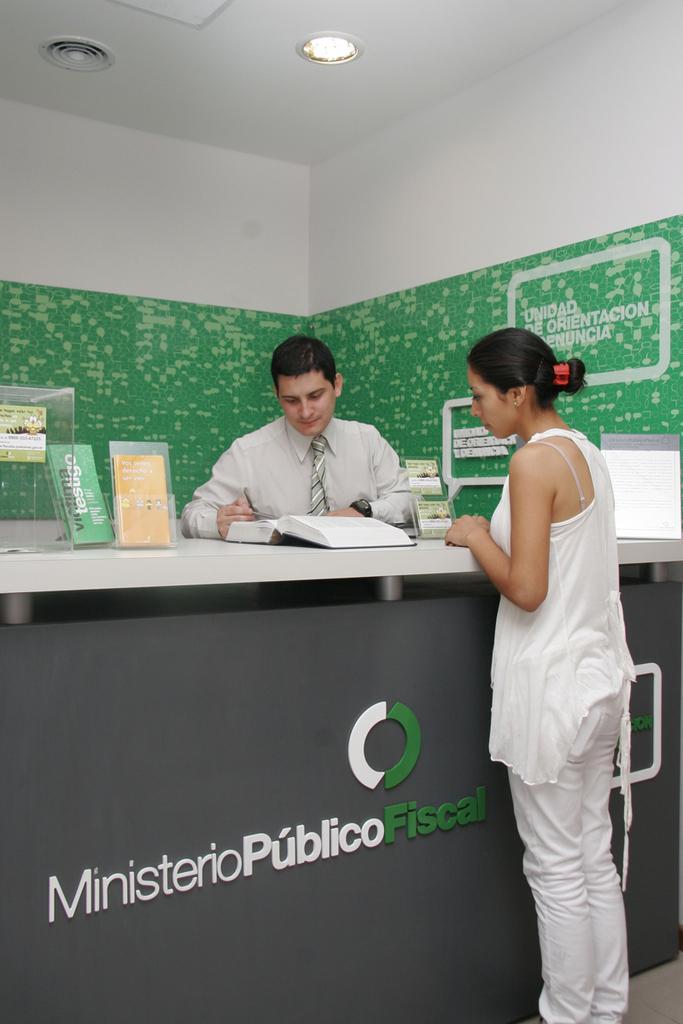How would you summarize this image in a sentence or two? In this image we can see a man and a woman standing beside a table containing a book, a glass container and some boards on it. On the bottom of the image we can see a board under a table containing some text on it. On the backside we can see a wall with some text and a roof with a ceiling light. 